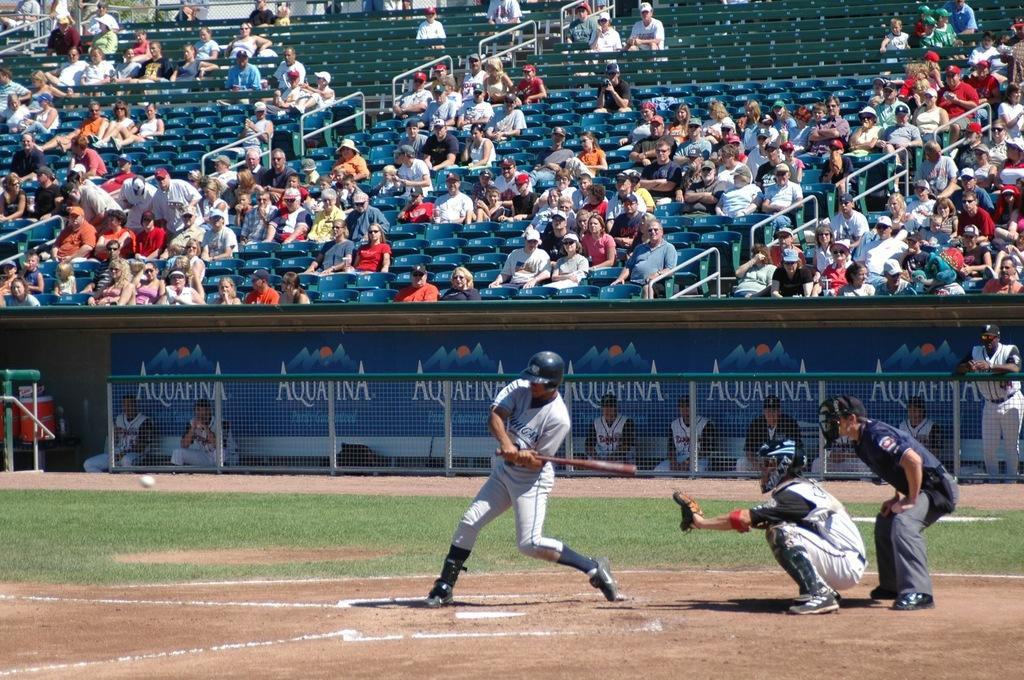Provide a one-sentence caption for the provided image. a baseball player is getting ready to swing his bat with an aquafina logo in the dugout. 